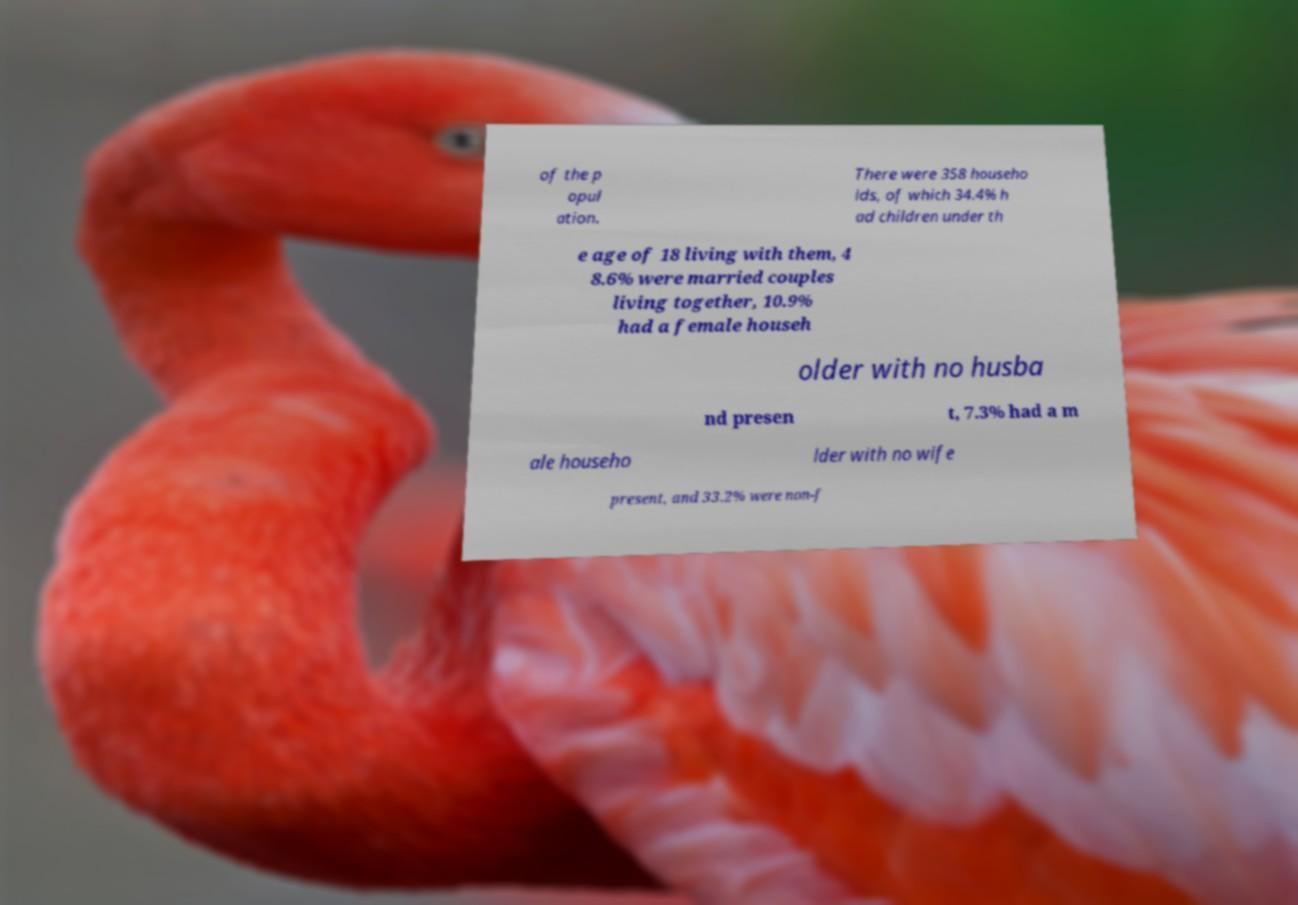Can you accurately transcribe the text from the provided image for me? of the p opul ation. There were 358 househo lds, of which 34.4% h ad children under th e age of 18 living with them, 4 8.6% were married couples living together, 10.9% had a female househ older with no husba nd presen t, 7.3% had a m ale househo lder with no wife present, and 33.2% were non-f 